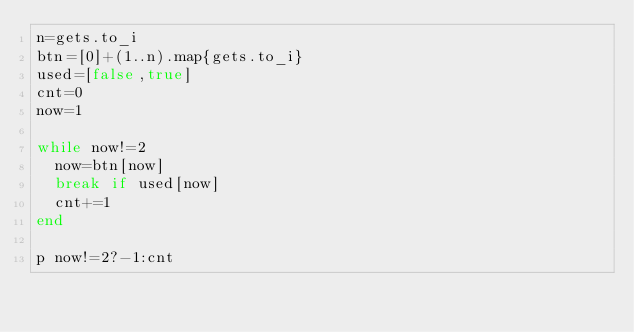<code> <loc_0><loc_0><loc_500><loc_500><_Ruby_>n=gets.to_i
btn=[0]+(1..n).map{gets.to_i}
used=[false,true]
cnt=0
now=1

while now!=2
  now=btn[now]
  break if used[now]
  cnt+=1
end

p now!=2?-1:cnt</code> 